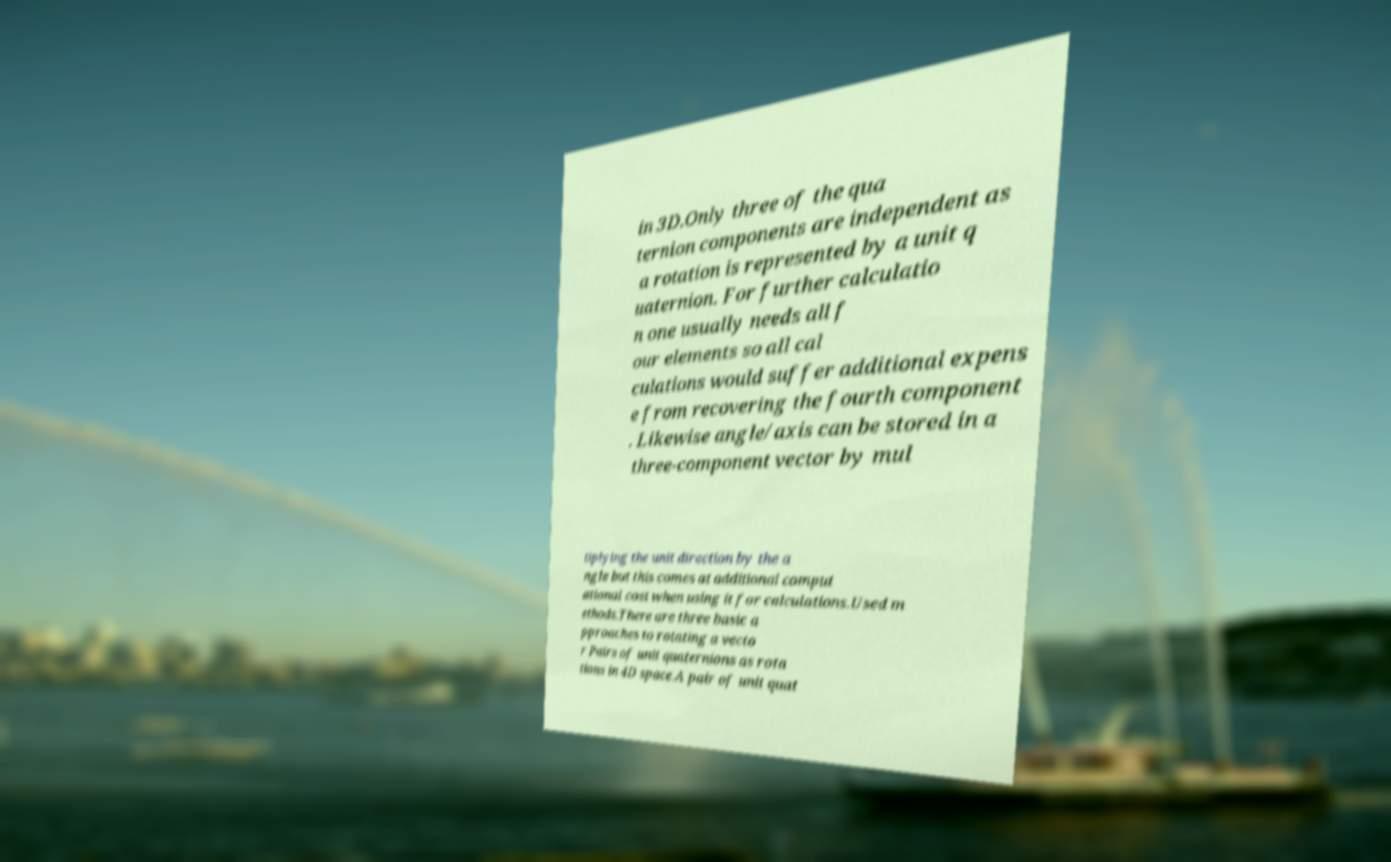What messages or text are displayed in this image? I need them in a readable, typed format. in 3D.Only three of the qua ternion components are independent as a rotation is represented by a unit q uaternion. For further calculatio n one usually needs all f our elements so all cal culations would suffer additional expens e from recovering the fourth component . Likewise angle/axis can be stored in a three-component vector by mul tiplying the unit direction by the a ngle but this comes at additional comput ational cost when using it for calculations.Used m ethods.There are three basic a pproaches to rotating a vecto r Pairs of unit quaternions as rota tions in 4D space.A pair of unit quat 